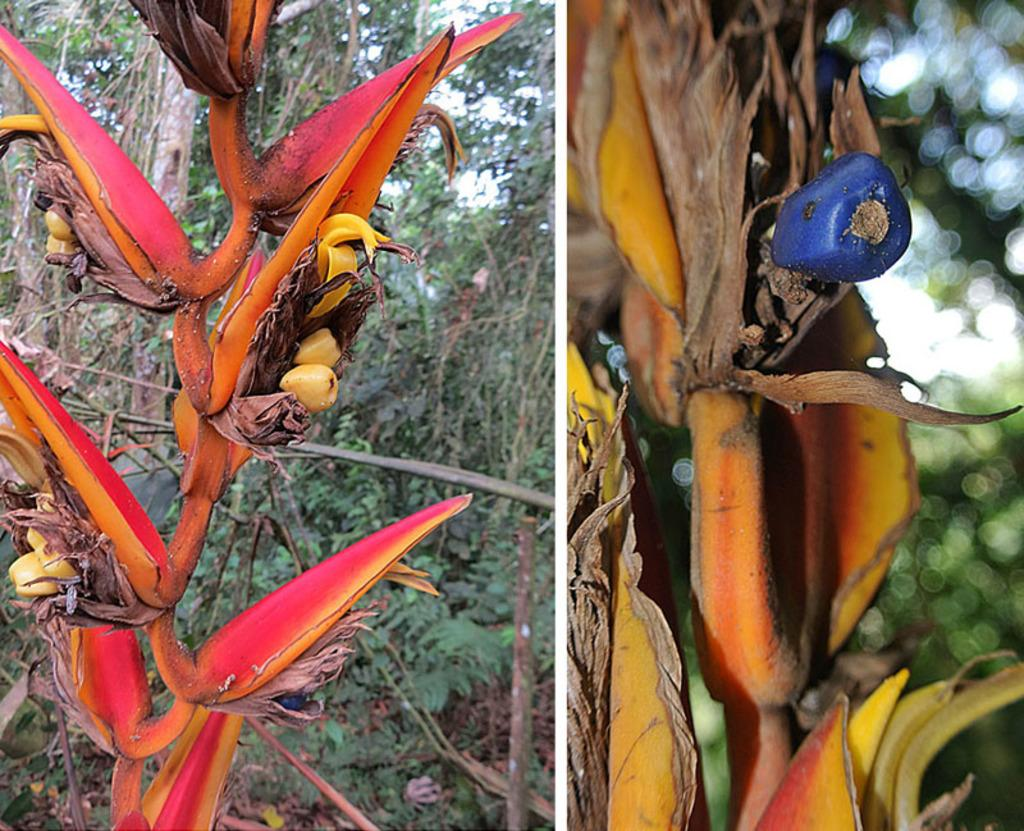What type of artwork is depicted in the image? The image is a collage. What subjects are featured in the collage? The collage contains pictures of plants and trees. How many acres of plantation can be seen in the image? There is no plantation present in the image; it contains pictures of plants and trees. What type of corn is visible in the image? There is no corn present in the image. 